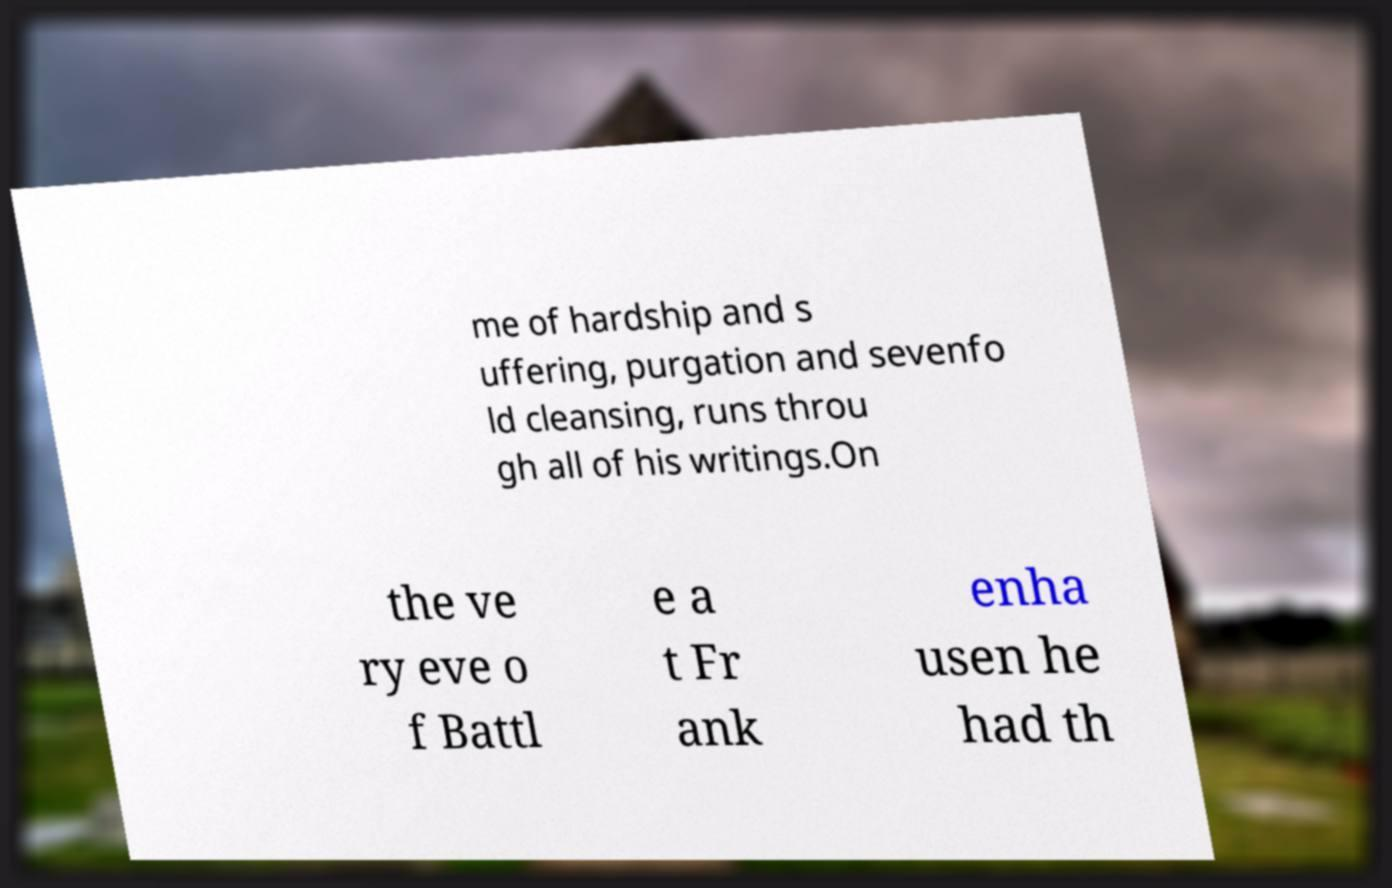Can you read and provide the text displayed in the image?This photo seems to have some interesting text. Can you extract and type it out for me? me of hardship and s uffering, purgation and sevenfo ld cleansing, runs throu gh all of his writings.On the ve ry eve o f Battl e a t Fr ank enha usen he had th 